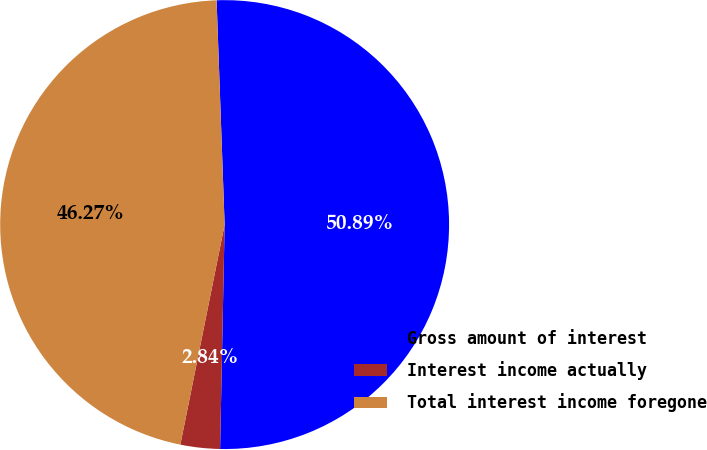Convert chart to OTSL. <chart><loc_0><loc_0><loc_500><loc_500><pie_chart><fcel>Gross amount of interest<fcel>Interest income actually<fcel>Total interest income foregone<nl><fcel>50.89%<fcel>2.84%<fcel>46.27%<nl></chart> 